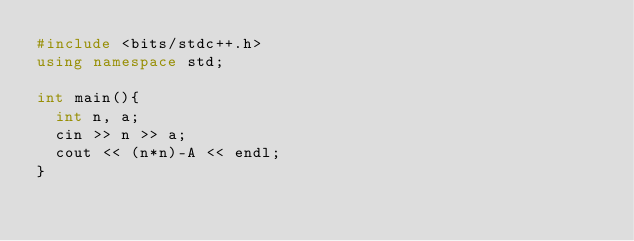<code> <loc_0><loc_0><loc_500><loc_500><_C++_>#include <bits/stdc++.h>
using namespace std;
 
int main(){
  int n, a;
  cin >> n >> a;  
  cout << (n*n)-A << endl;
}</code> 